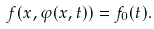<formula> <loc_0><loc_0><loc_500><loc_500>f ( x , \varphi ( x , t ) ) = f _ { 0 } ( t ) .</formula> 